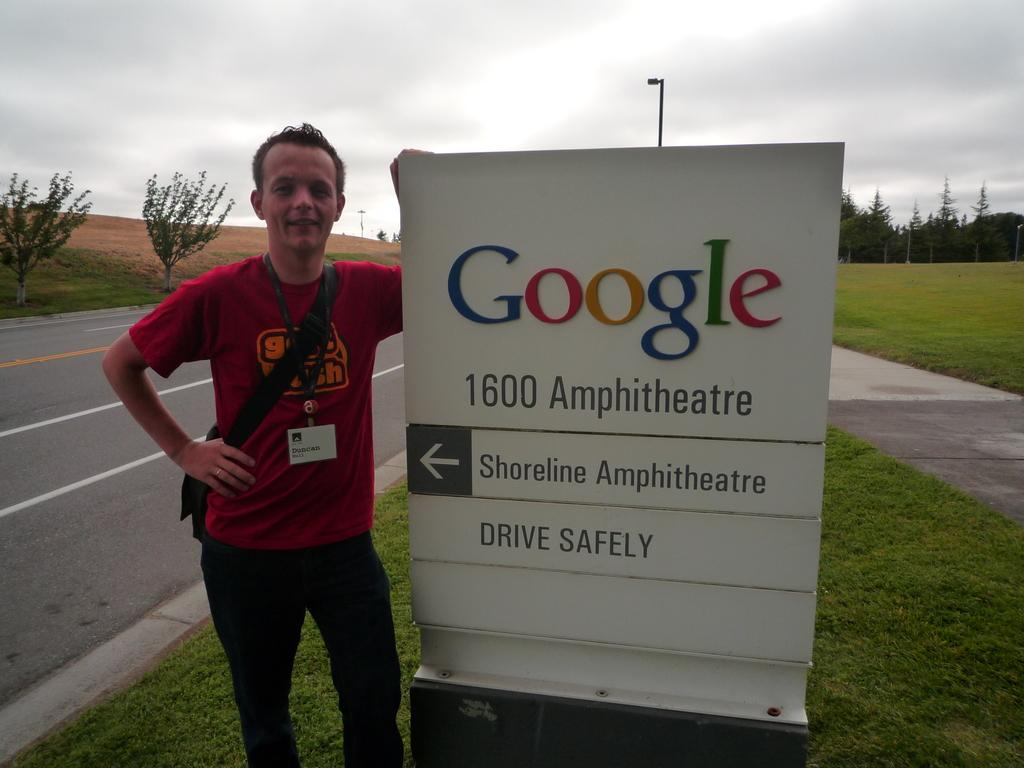<image>
Create a compact narrative representing the image presented. A young man standing by the Google 1600 Amphitheater sign. 